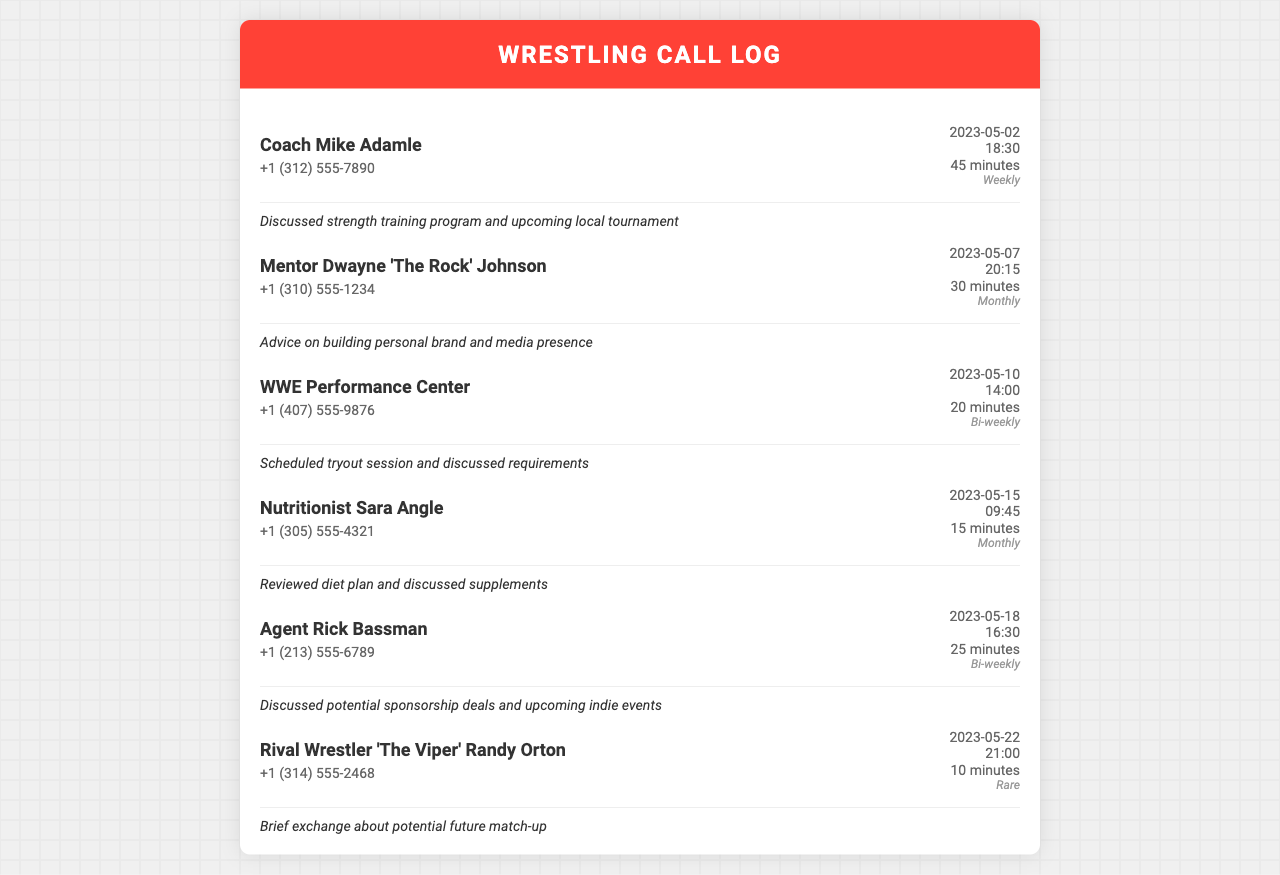What is the name of the coach with the longest call duration? The longest call duration is 45 minutes with Coach Mike Adamle.
Answer: Coach Mike Adamle How often do you talk to the mentor Dwayne 'The Rock' Johnson? The frequency of calls with Dwayne 'The Rock' Johnson is mentioned as monthly.
Answer: Monthly What is the date of the call with Nutritionist Sara Angle? The date of the call with Nutritionist Sara Angle is listed as May 15, 2023.
Answer: 2023-05-15 How many minutes did the call with the WWE Performance Center last? The call duration with the WWE Performance Center is stated as 20 minutes.
Answer: 20 minutes Which rival wrestler is mentioned in the call log? The rival wrestler mentioned in the log is 'The Viper' Randy Orton.
Answer: 'The Viper' Randy Orton What type of session was scheduled during the call with the WWE Performance Center? The session type scheduled was a tryout session.
Answer: Tryout session How many total calls were made to Coach Mike Adamle? The frequency of calls to Coach Mike Adamle is weekly, implying there are several.
Answer: Weekly What were the general topics discussed during the call with Agent Rick Bassman? The topics discussed included potential sponsorship deals and upcoming indie events.
Answer: Sponsorship deals and upcoming indie events 